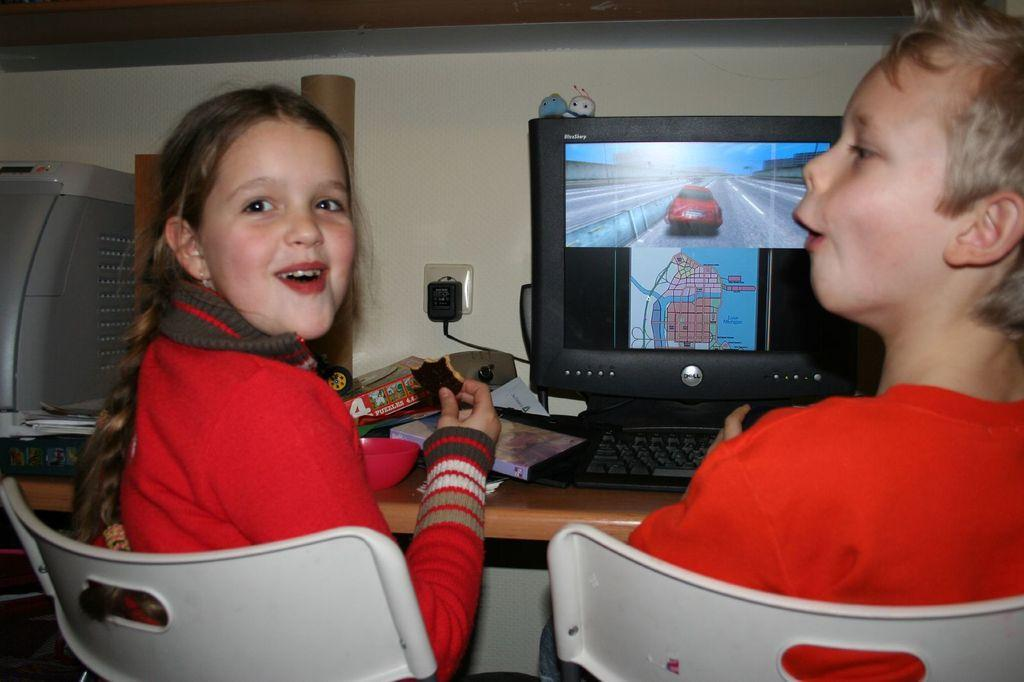How many people are in the image? There are two people in the image, a girl and a boy. What are the girl and boy doing in the image? Both the girl and boy are sitting on chairs. What is on the table in the image? There is a monitor, a keyboard, and other objects on the table. What might the girl and boy be using the monitor and keyboard for? They might be using the monitor and keyboard for a computer-related activity, such as gaming or working. What type of design can be seen on the earth in the image? There is no earth present in the image; it features a girl and a boy sitting at a table with a monitor and keyboard. 